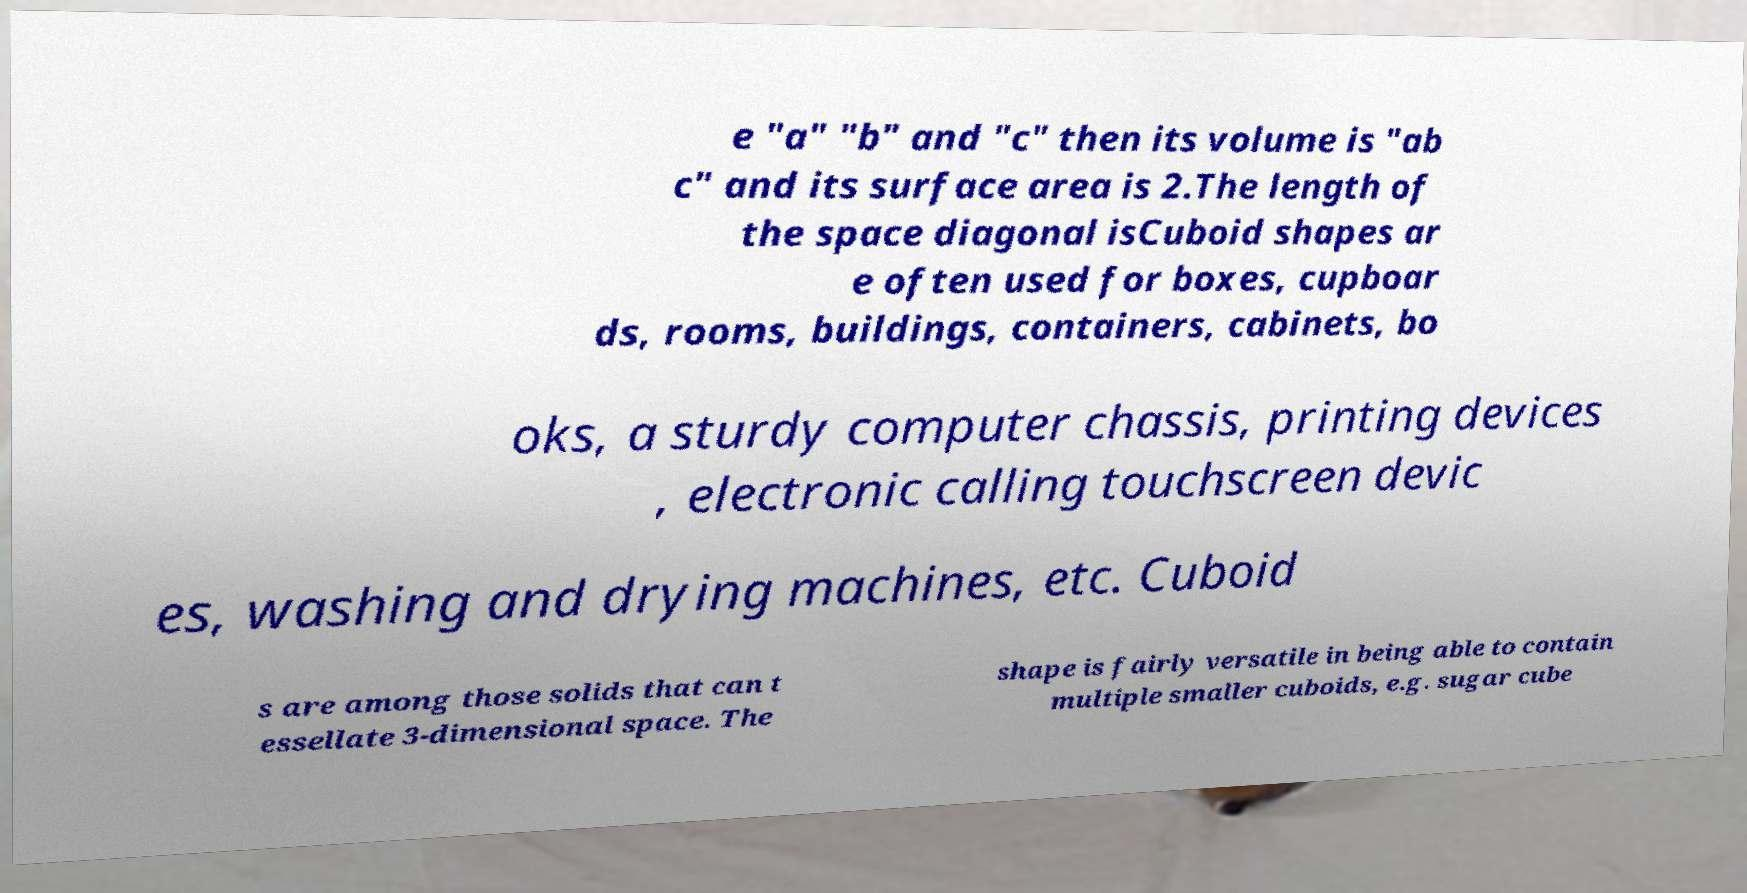Can you read and provide the text displayed in the image?This photo seems to have some interesting text. Can you extract and type it out for me? e "a" "b" and "c" then its volume is "ab c" and its surface area is 2.The length of the space diagonal isCuboid shapes ar e often used for boxes, cupboar ds, rooms, buildings, containers, cabinets, bo oks, a sturdy computer chassis, printing devices , electronic calling touchscreen devic es, washing and drying machines, etc. Cuboid s are among those solids that can t essellate 3-dimensional space. The shape is fairly versatile in being able to contain multiple smaller cuboids, e.g. sugar cube 